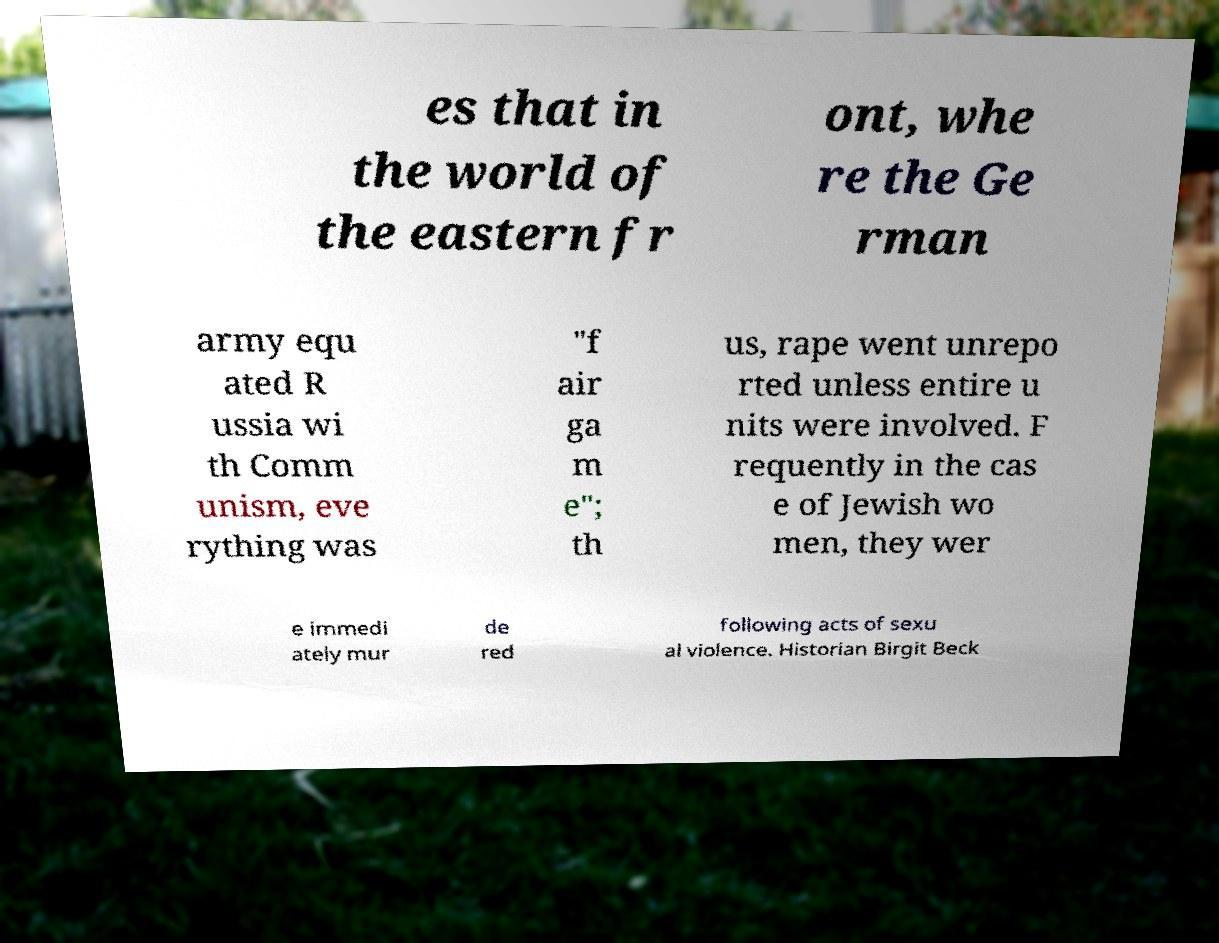Could you extract and type out the text from this image? es that in the world of the eastern fr ont, whe re the Ge rman army equ ated R ussia wi th Comm unism, eve rything was "f air ga m e"; th us, rape went unrepo rted unless entire u nits were involved. F requently in the cas e of Jewish wo men, they wer e immedi ately mur de red following acts of sexu al violence. Historian Birgit Beck 